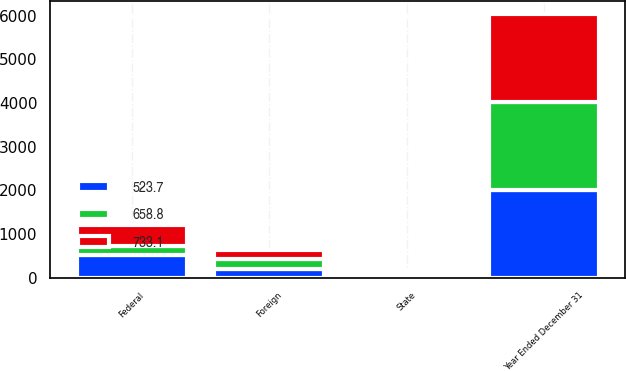Convert chart to OTSL. <chart><loc_0><loc_0><loc_500><loc_500><stacked_bar_chart><ecel><fcel>Year Ended December 31<fcel>Federal<fcel>State<fcel>Foreign<nl><fcel>523.7<fcel>2015<fcel>521.8<fcel>61.1<fcel>205.4<nl><fcel>733.1<fcel>2014<fcel>482.4<fcel>59<fcel>215.4<nl><fcel>658.8<fcel>2013<fcel>191.4<fcel>20.9<fcel>214.1<nl></chart> 